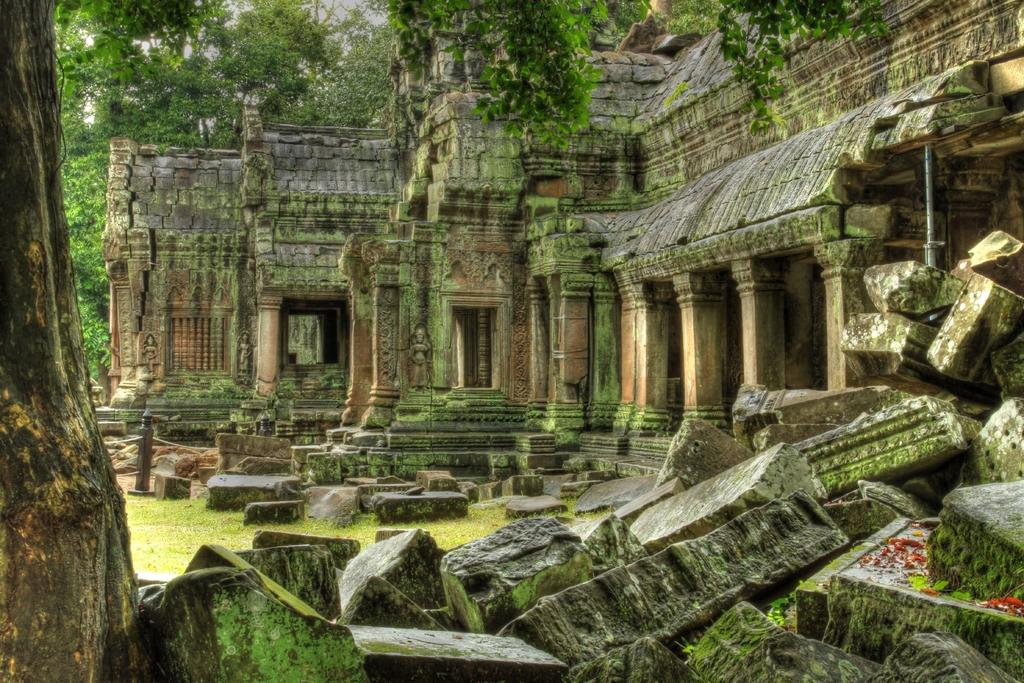What type of structure is in the picture? There is a temple in the picture. What can be seen on the walls of the temple? There are sculptures on the walls of the temple. What is on the ground near the temple? There are rocks on the ground. What can be seen in the background of the picture? There are trees in the backdrop of the picture. What type of lumber is being used to construct the temple in the image? There is no mention of lumber being used in the construction of the temple in the image. Can you see any pets in the image? There are no pets visible in the image. 